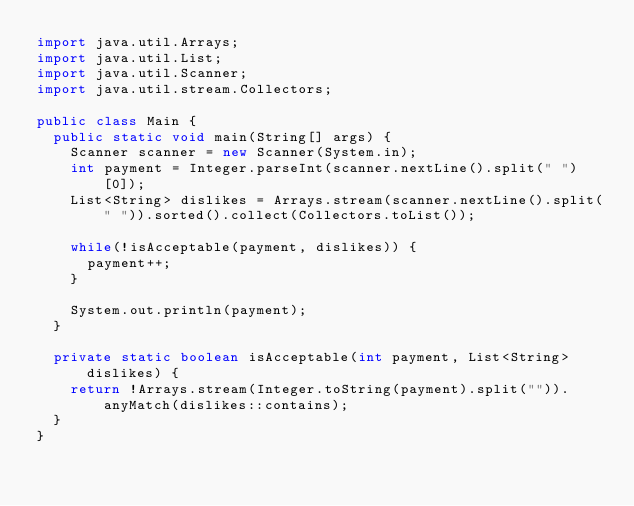Convert code to text. <code><loc_0><loc_0><loc_500><loc_500><_Java_>import java.util.Arrays;
import java.util.List;
import java.util.Scanner;
import java.util.stream.Collectors;

public class Main {
	public static void main(String[] args) {
		Scanner scanner = new Scanner(System.in);
		int payment = Integer.parseInt(scanner.nextLine().split(" ")[0]);
		List<String> dislikes = Arrays.stream(scanner.nextLine().split(" ")).sorted().collect(Collectors.toList());

		while(!isAcceptable(payment, dislikes)) {
			payment++;
		}

		System.out.println(payment);
	}

	private static boolean isAcceptable(int payment, List<String> dislikes) {
		return !Arrays.stream(Integer.toString(payment).split("")).anyMatch(dislikes::contains);
	}
}
</code> 